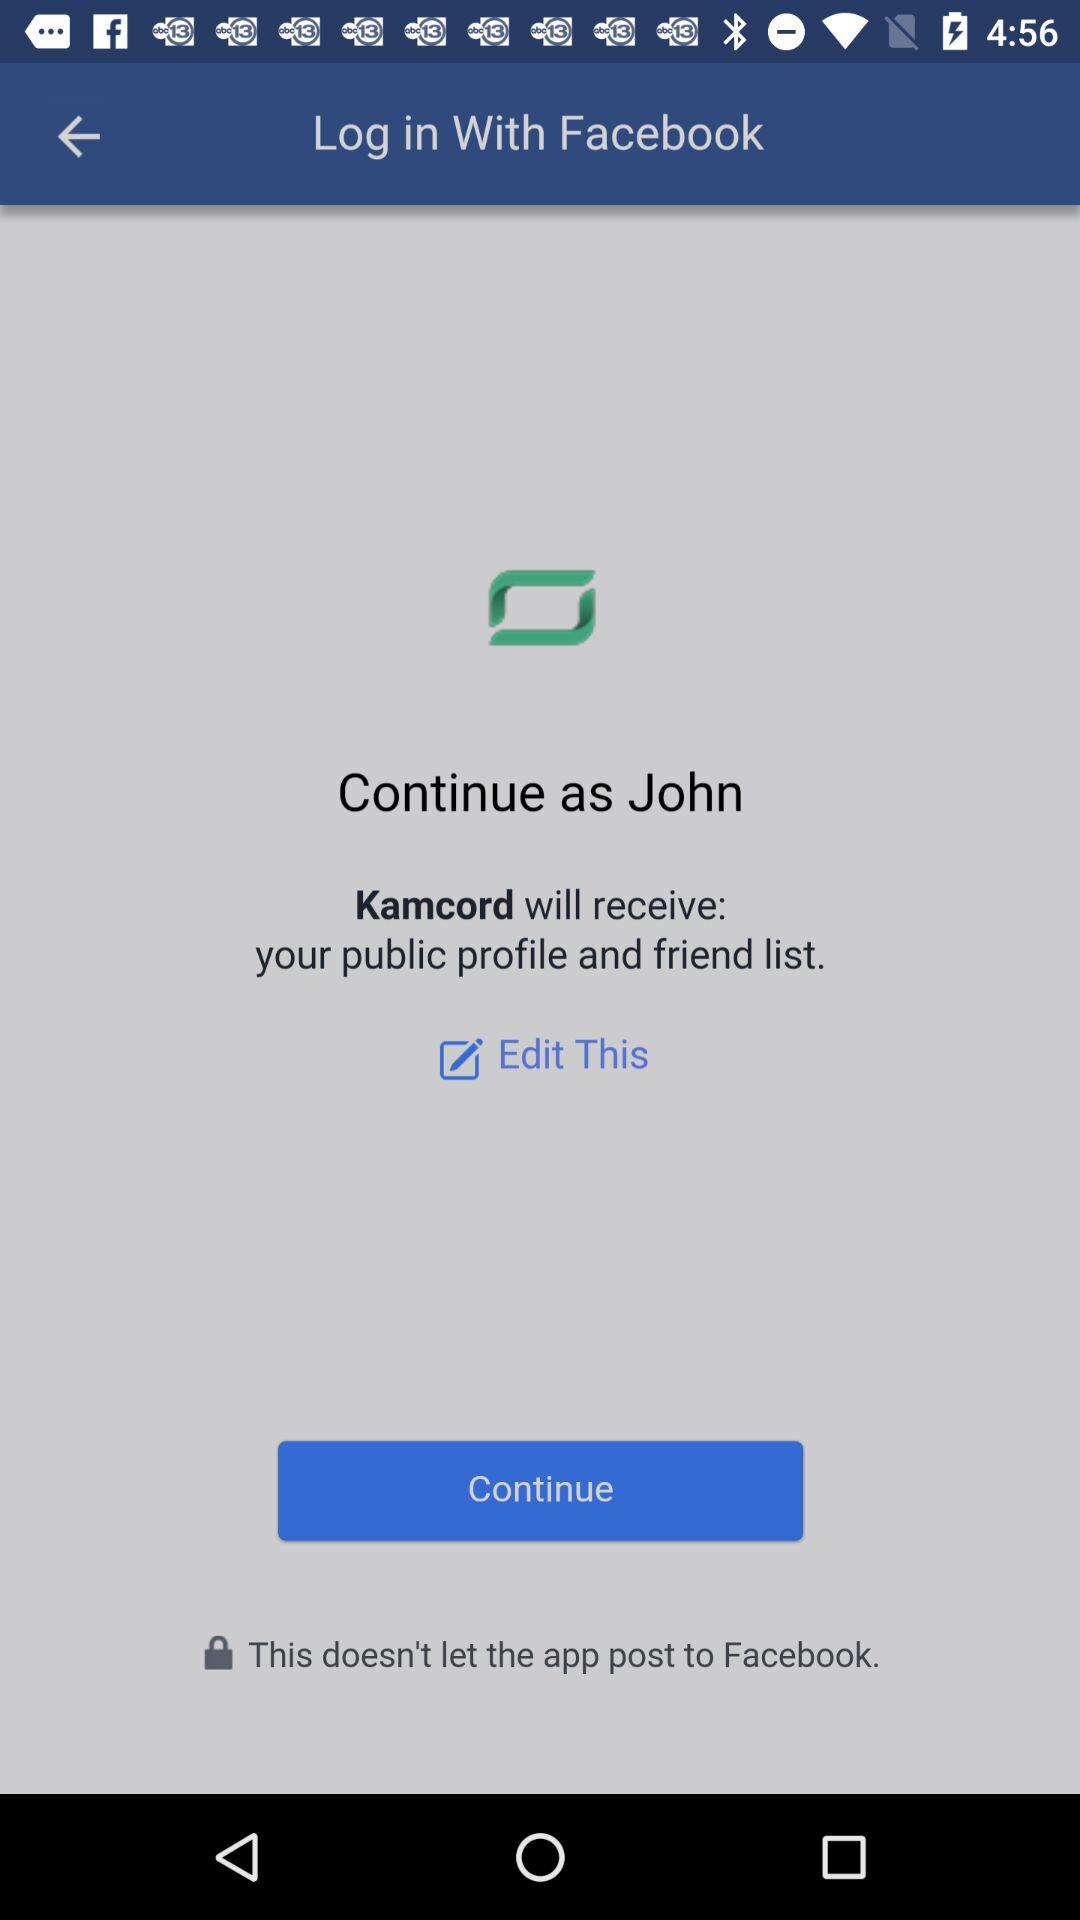What information will "Kamcord" receive? "Kamcord" will receive your public profile and friend list. 